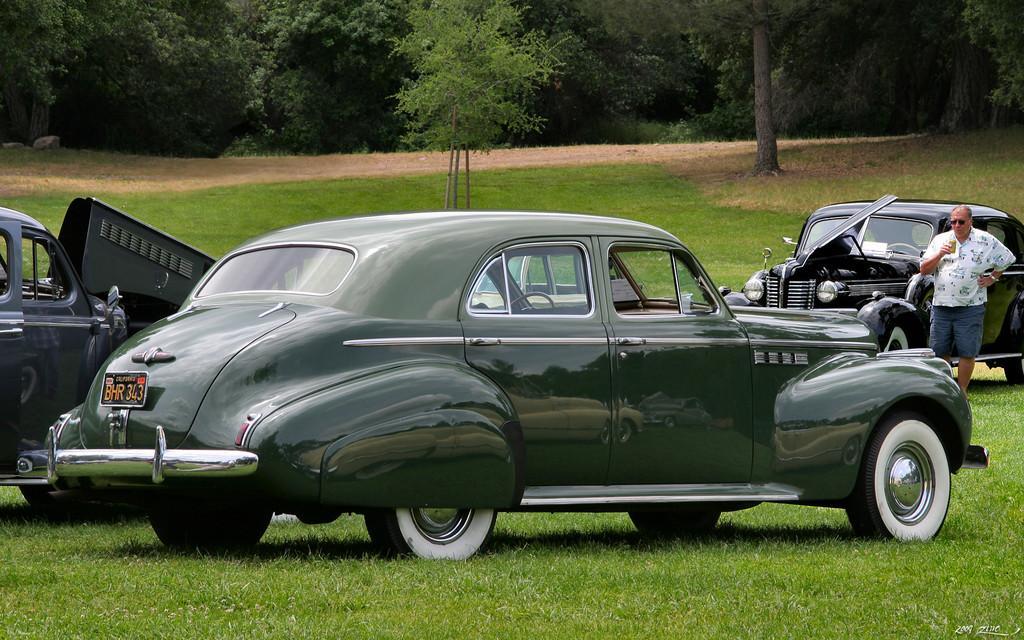Can you describe this image briefly? In the center of the image there are cars. At the bottom of the image there is grass. In the background of the image there are trees. To the right side of the image there is a person standing. 